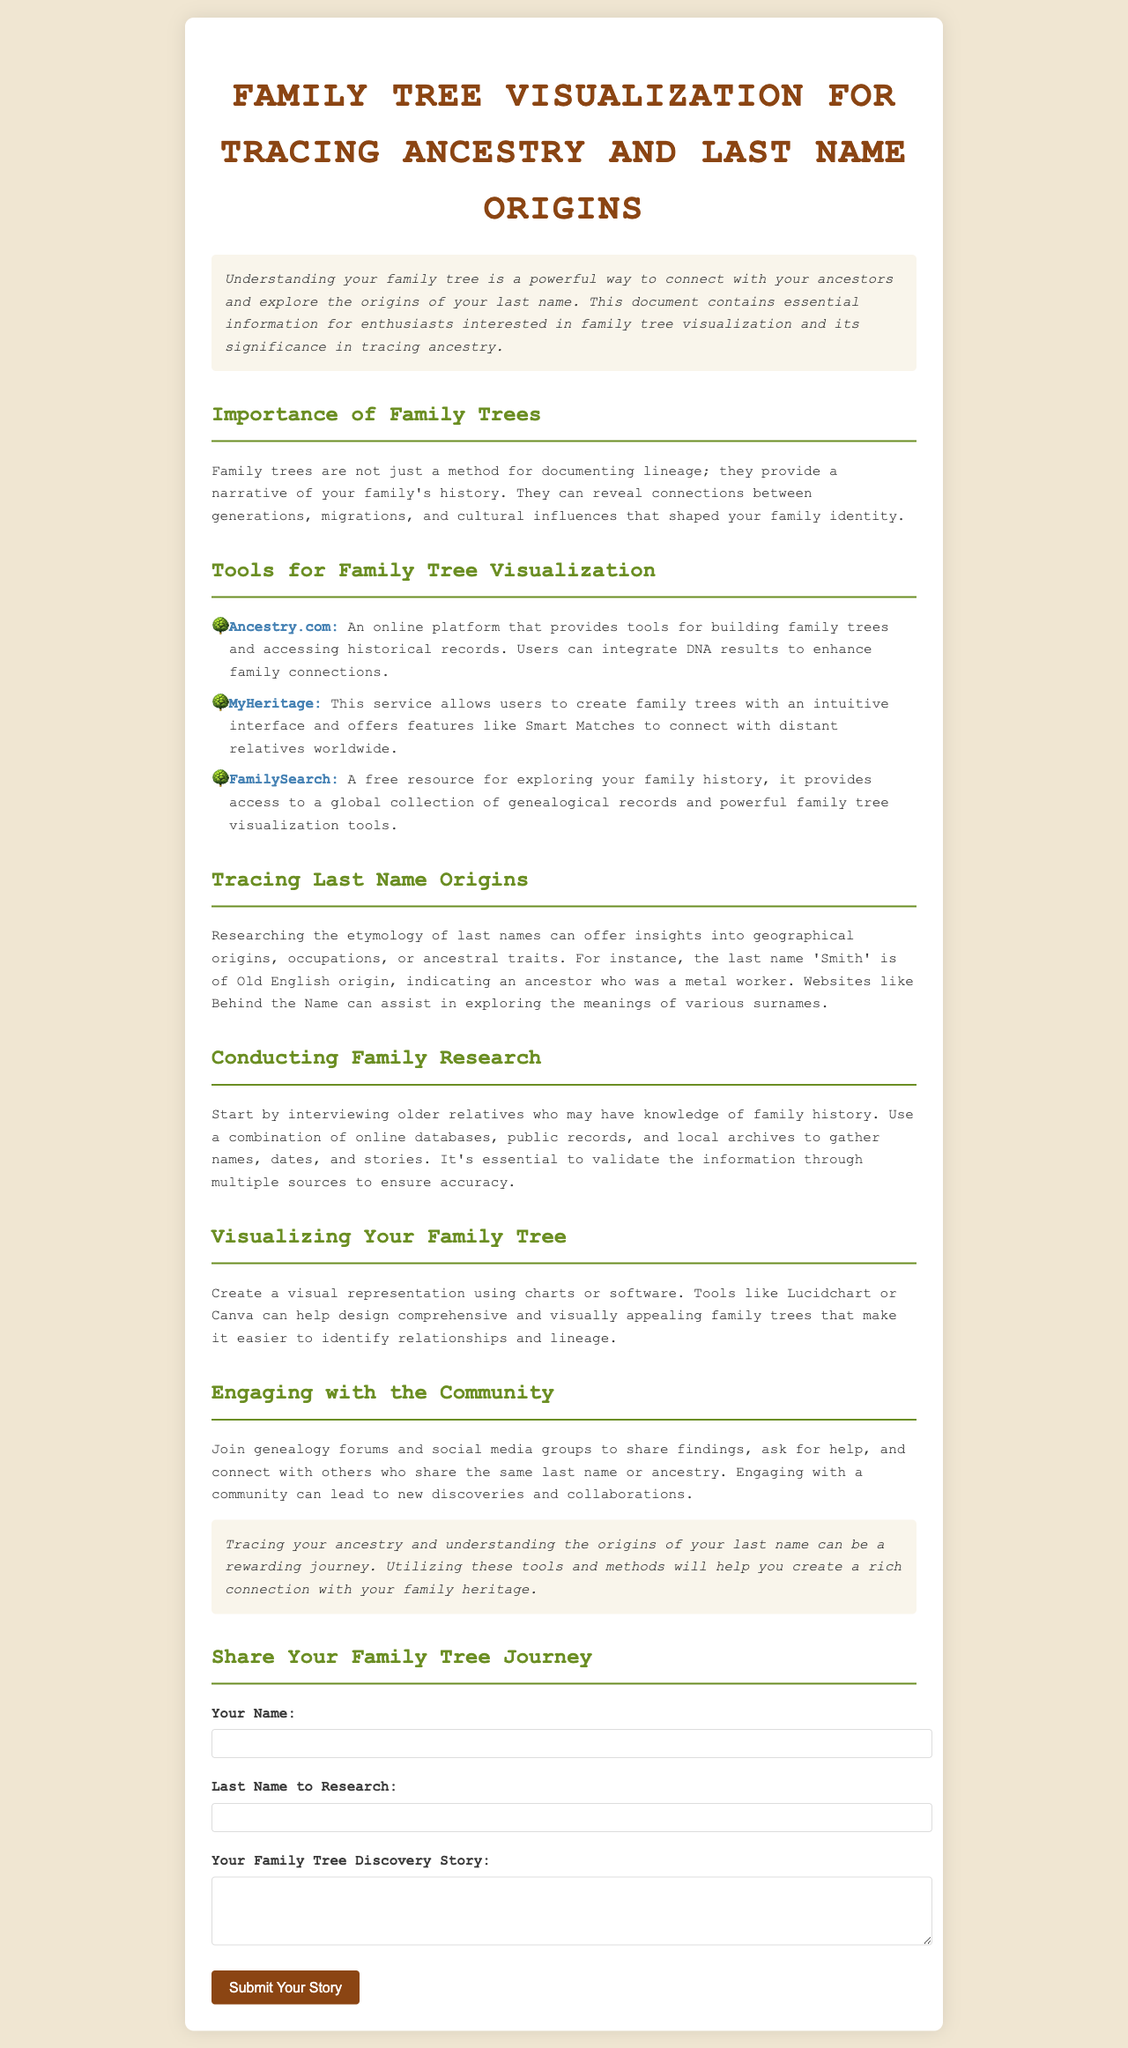What is the title of the document? The title is prominently displayed at the top of the document.
Answer: Family Tree Visualization for Tracing Ancestry and Last Name Origins What is one of the tools mentioned for family tree visualization? The document lists specific tools under the section about family tree visualization.
Answer: Ancestry.com What type of origin does the last name 'Smith' have? The document includes a specific example of last name origins and their meanings.
Answer: Old English Which website is suggested for exploring the meanings of surnames? The document refers to a specific website that assists with surname meanings.
Answer: Behind the Name How many tools for family tree visualization are listed? The document provides a list of tools. By counting them, we can find the total.
Answer: Three What is emphasized as important for conducting family research? The document discusses the importance of a specific activity related to family research.
Answer: Interviewing older relatives What is a benefit of engaging with genealogy forums? The document highlights one key advantage of connecting with others in genealogy forums.
Answer: New discoveries What should be used to validate family history information? The document stresses the importance of a particular action in family history research.
Answer: Multiple sources 